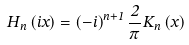Convert formula to latex. <formula><loc_0><loc_0><loc_500><loc_500>H _ { n } \left ( i x \right ) = \left ( - i \right ) ^ { n + 1 } \frac { 2 } { \pi } K _ { n } \left ( x \right )</formula> 